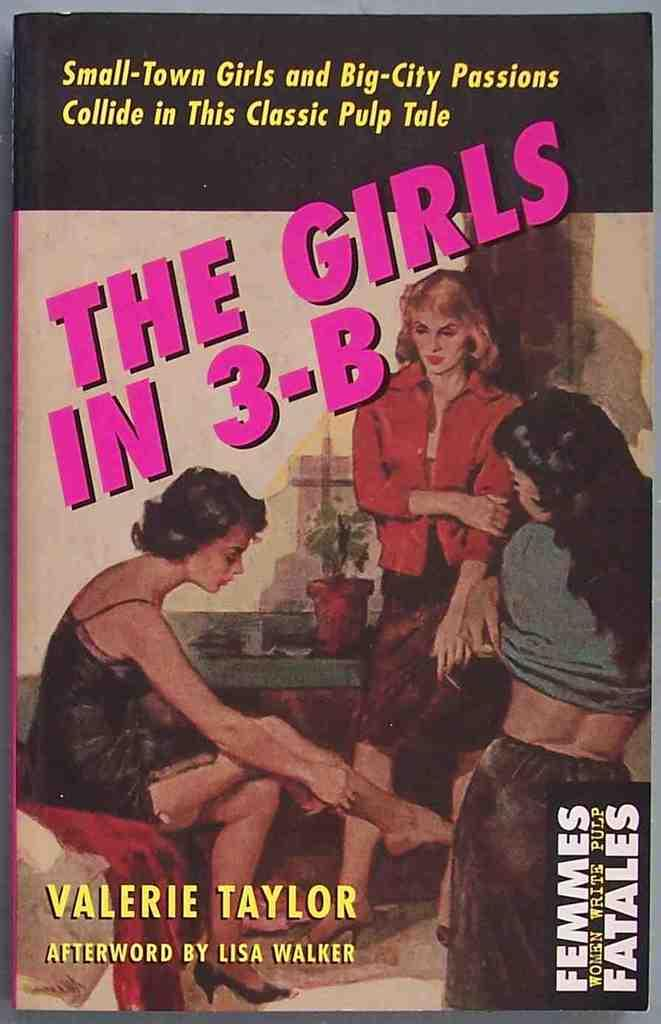<image>
Create a compact narrative representing the image presented. A pulp book titled The Girls in 3-B by Valerie Taylor. 